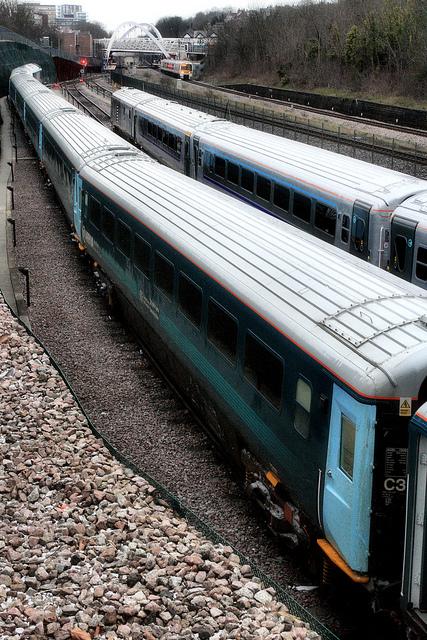How is one train different from the others?
Concise answer only. Longer. What color is the train door?
Be succinct. Blue. Are the trains close together?
Write a very short answer. Yes. Is there a train station up ahead?
Concise answer only. Yes. 